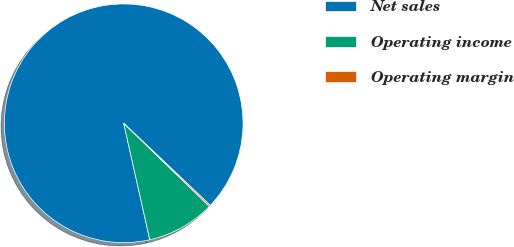<chart> <loc_0><loc_0><loc_500><loc_500><pie_chart><fcel>Net sales<fcel>Operating income<fcel>Operating margin<nl><fcel>90.58%<fcel>9.23%<fcel>0.19%<nl></chart> 